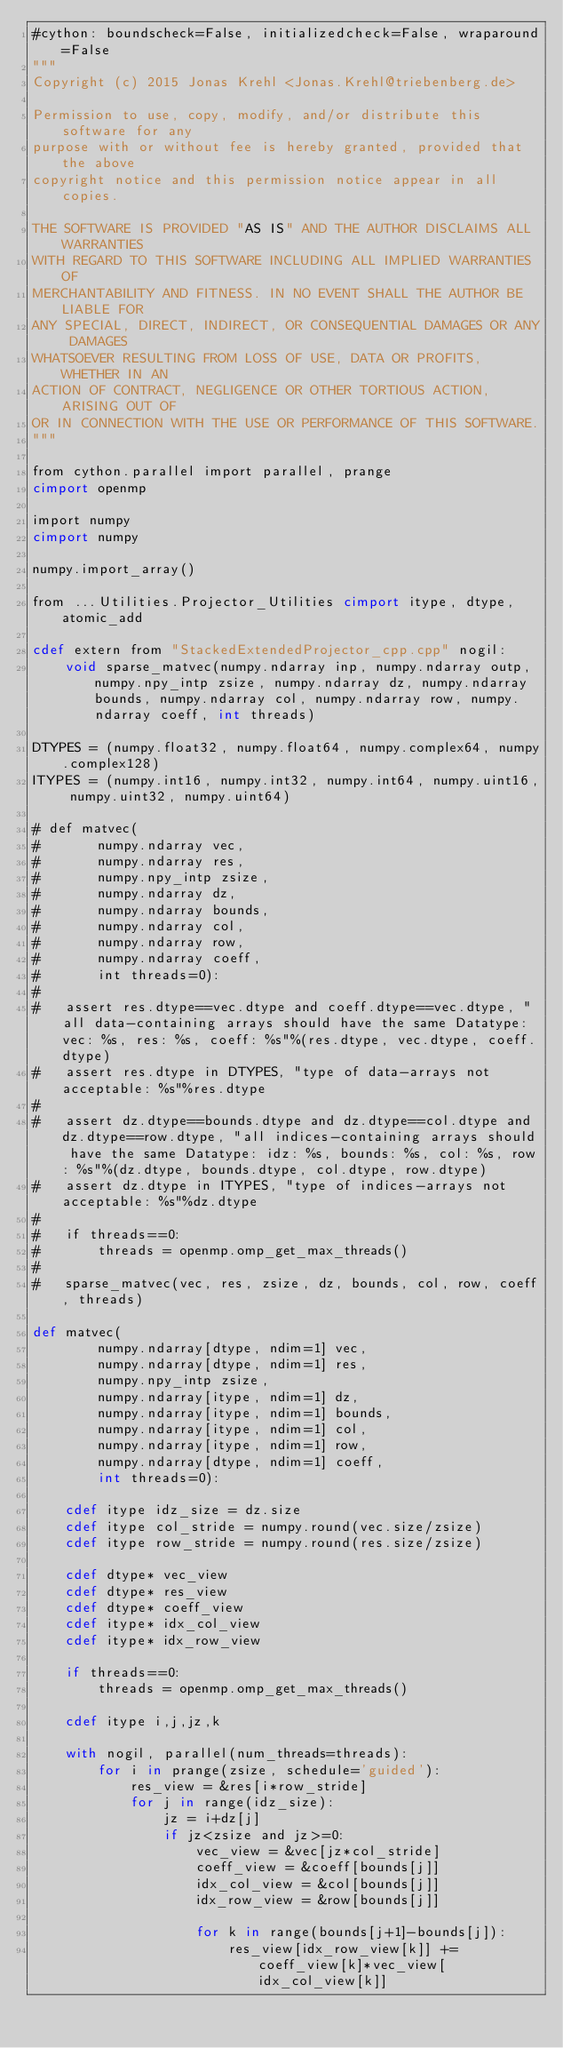Convert code to text. <code><loc_0><loc_0><loc_500><loc_500><_Cython_>#cython: boundscheck=False, initializedcheck=False, wraparound=False
"""
Copyright (c) 2015 Jonas Krehl <Jonas.Krehl@triebenberg.de>

Permission to use, copy, modify, and/or distribute this software for any
purpose with or without fee is hereby granted, provided that the above
copyright notice and this permission notice appear in all copies.

THE SOFTWARE IS PROVIDED "AS IS" AND THE AUTHOR DISCLAIMS ALL WARRANTIES
WITH REGARD TO THIS SOFTWARE INCLUDING ALL IMPLIED WARRANTIES OF
MERCHANTABILITY AND FITNESS. IN NO EVENT SHALL THE AUTHOR BE LIABLE FOR
ANY SPECIAL, DIRECT, INDIRECT, OR CONSEQUENTIAL DAMAGES OR ANY DAMAGES
WHATSOEVER RESULTING FROM LOSS OF USE, DATA OR PROFITS, WHETHER IN AN
ACTION OF CONTRACT, NEGLIGENCE OR OTHER TORTIOUS ACTION, ARISING OUT OF
OR IN CONNECTION WITH THE USE OR PERFORMANCE OF THIS SOFTWARE.
"""

from cython.parallel import parallel, prange
cimport openmp

import numpy
cimport numpy

numpy.import_array()

from ...Utilities.Projector_Utilities cimport itype, dtype, atomic_add

cdef extern from "StackedExtendedProjector_cpp.cpp" nogil:
	void sparse_matvec(numpy.ndarray inp, numpy.ndarray outp, numpy.npy_intp zsize, numpy.ndarray dz, numpy.ndarray bounds, numpy.ndarray col, numpy.ndarray row, numpy.ndarray coeff, int threads)

DTYPES = (numpy.float32, numpy.float64, numpy.complex64, numpy.complex128)
ITYPES = (numpy.int16, numpy.int32, numpy.int64, numpy.uint16, numpy.uint32, numpy.uint64)

# def matvec(
# 		numpy.ndarray vec,
# 		numpy.ndarray res,
# 		numpy.npy_intp zsize,
# 		numpy.ndarray dz,
# 		numpy.ndarray bounds,
# 		numpy.ndarray col,
# 		numpy.ndarray row,
# 		numpy.ndarray coeff,
# 		int threads=0):
#
# 	assert res.dtype==vec.dtype and coeff.dtype==vec.dtype, "all data-containing arrays should have the same Datatype: vec: %s, res: %s, coeff: %s"%(res.dtype, vec.dtype, coeff.dtype)
# 	assert res.dtype in DTYPES, "type of data-arrays not acceptable: %s"%res.dtype
#
# 	assert dz.dtype==bounds.dtype and dz.dtype==col.dtype and dz.dtype==row.dtype, "all indices-containing arrays should have the same Datatype: idz: %s, bounds: %s, col: %s, row: %s"%(dz.dtype, bounds.dtype, col.dtype, row.dtype)
# 	assert dz.dtype in ITYPES, "type of indices-arrays not acceptable: %s"%dz.dtype
#
# 	if threads==0:
# 		threads = openmp.omp_get_max_threads()
#
# 	sparse_matvec(vec, res, zsize, dz, bounds, col, row, coeff, threads)

def matvec(
		numpy.ndarray[dtype, ndim=1] vec,
		numpy.ndarray[dtype, ndim=1] res,
		numpy.npy_intp zsize,
		numpy.ndarray[itype, ndim=1] dz,
		numpy.ndarray[itype, ndim=1] bounds,
		numpy.ndarray[itype, ndim=1] col,
		numpy.ndarray[itype, ndim=1] row,
		numpy.ndarray[dtype, ndim=1] coeff,
		int threads=0):

	cdef itype idz_size = dz.size
	cdef itype col_stride = numpy.round(vec.size/zsize)
	cdef itype row_stride = numpy.round(res.size/zsize)

	cdef dtype* vec_view
	cdef dtype* res_view
	cdef dtype* coeff_view
	cdef itype* idx_col_view
	cdef itype* idx_row_view

	if threads==0:
		threads = openmp.omp_get_max_threads()

	cdef itype i,j,jz,k

	with nogil, parallel(num_threads=threads):
		for i in prange(zsize, schedule='guided'):
			res_view = &res[i*row_stride]
			for j in range(idz_size):
				jz = i+dz[j]
				if jz<zsize and jz>=0:
					vec_view = &vec[jz*col_stride]
					coeff_view = &coeff[bounds[j]]
					idx_col_view = &col[bounds[j]]
					idx_row_view = &row[bounds[j]]

					for k in range(bounds[j+1]-bounds[j]):
						res_view[idx_row_view[k]] += coeff_view[k]*vec_view[idx_col_view[k]]
</code> 